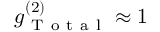Convert formula to latex. <formula><loc_0><loc_0><loc_500><loc_500>g _ { T o t a l } ^ { ( 2 ) } \approx 1</formula> 